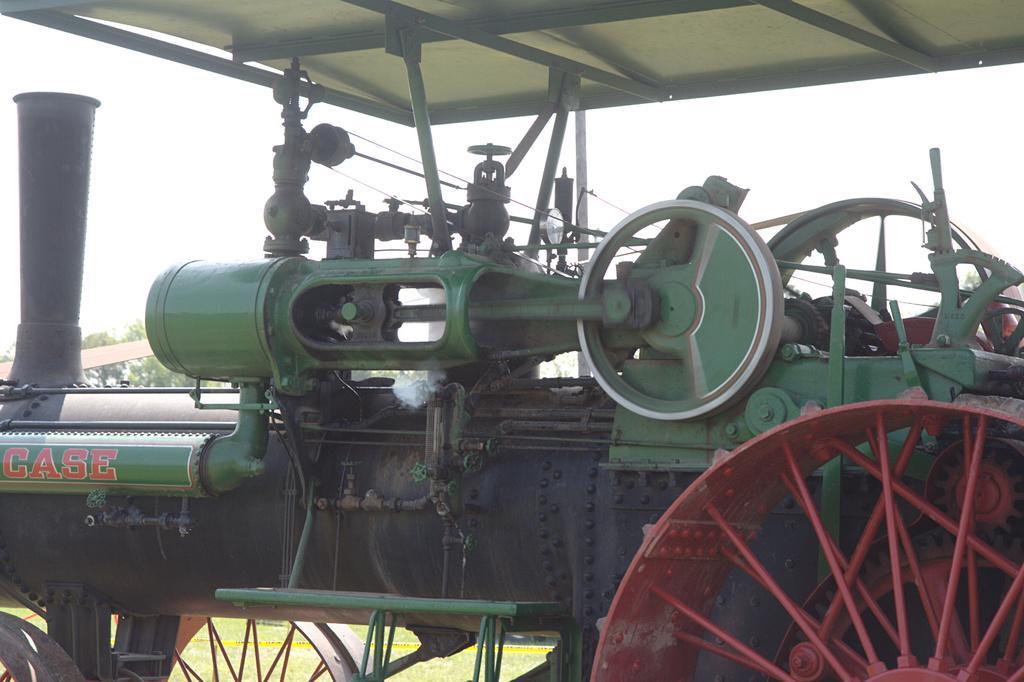In one or two sentences, can you explain what this image depicts? In the center of the image we can see a vehicle, which is in a green and red color. And we can see some text and a few other objects on a vehicle. In the background, we can see the sky, trees, grass and caution tape. 